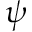Convert formula to latex. <formula><loc_0><loc_0><loc_500><loc_500>\psi</formula> 